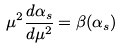Convert formula to latex. <formula><loc_0><loc_0><loc_500><loc_500>\mu ^ { 2 } \frac { d \alpha _ { s } } { d \mu ^ { 2 } } = \beta ( \alpha _ { s } )</formula> 